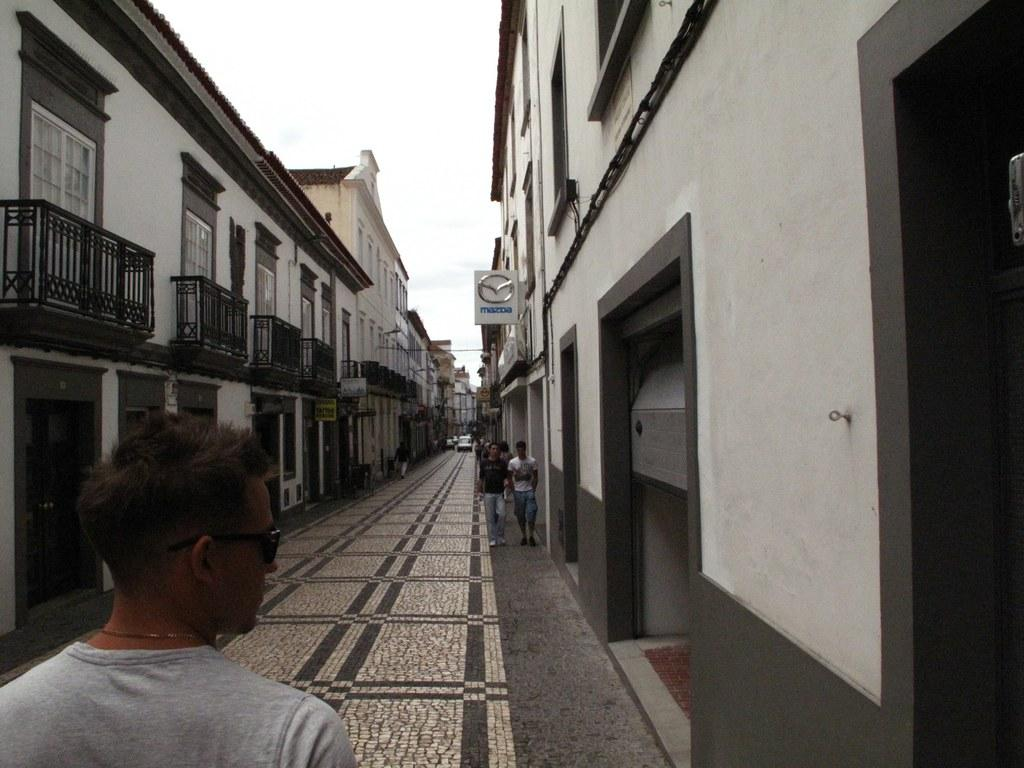What is the main feature of the image? There is a road in the image. What are the people in the image doing? People are walking on the road. What can be seen near the road? Cars are parked alongside the road. What surrounds the road in the image? There are buildings on either side of the road. Can you hear the waves crashing in the image? There are no waves present in the image, as it features a road with people walking and cars parked alongside it. 